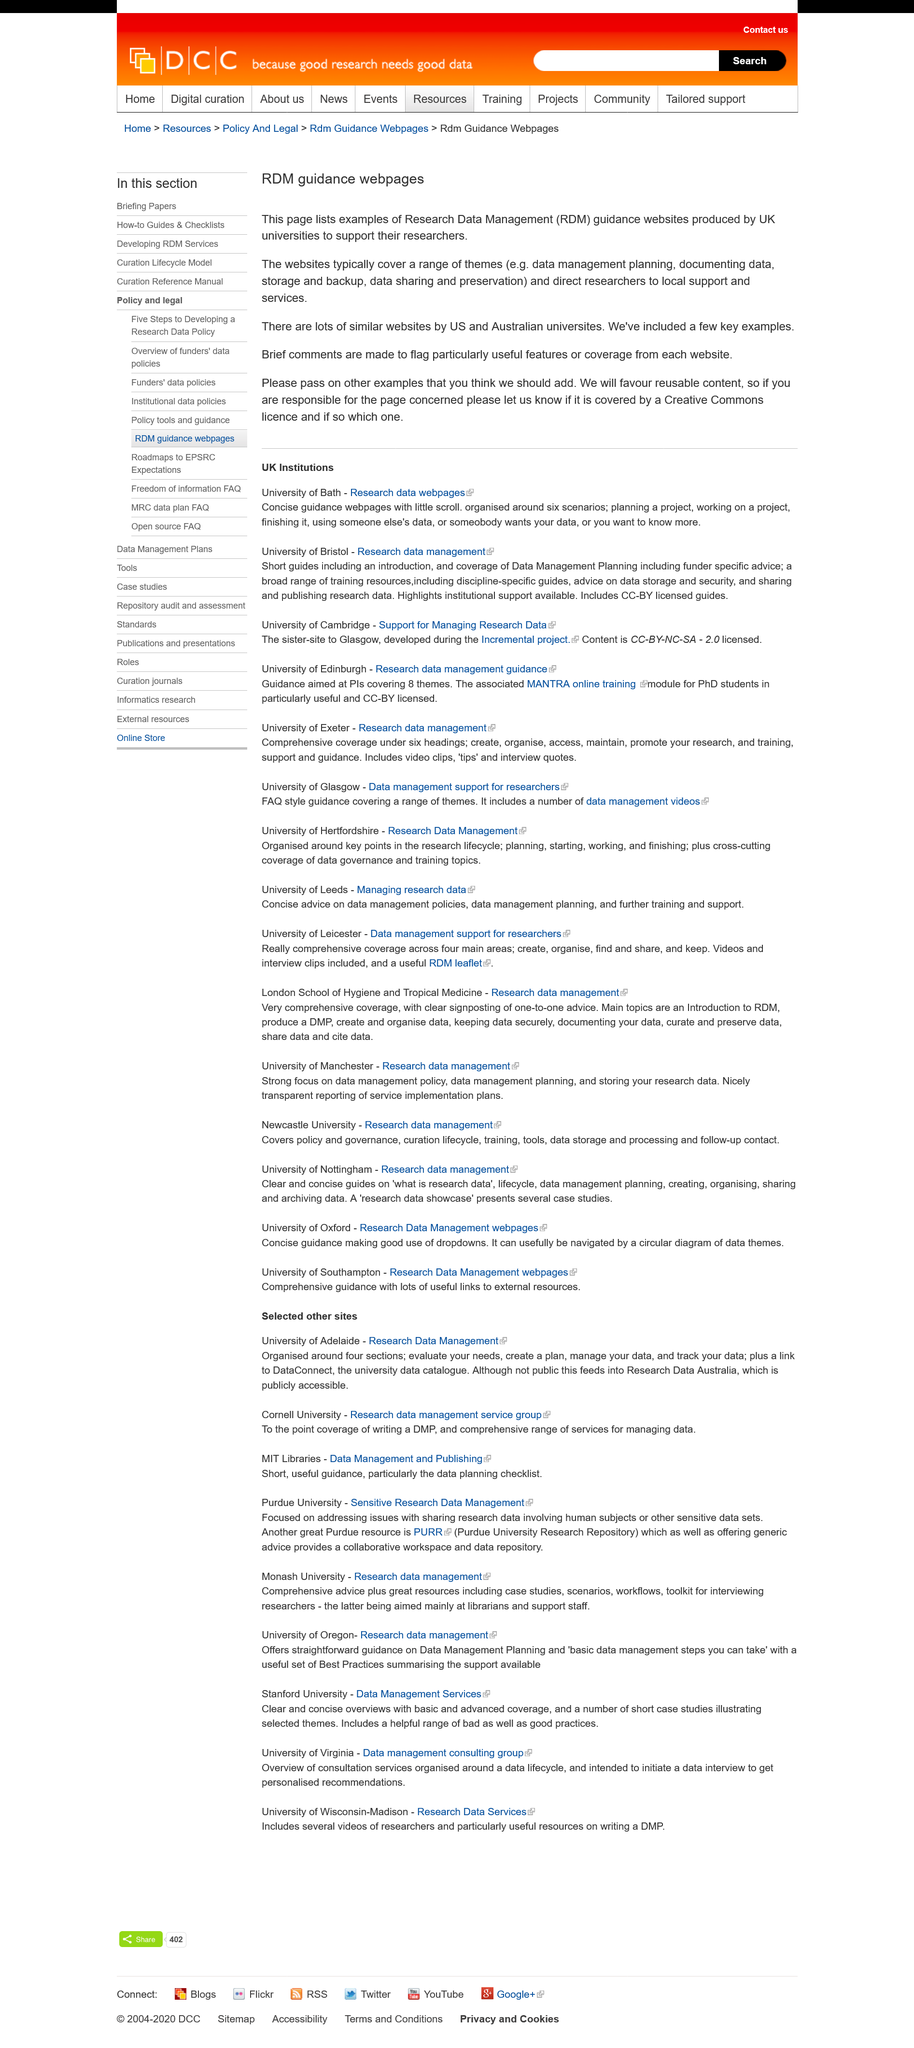Outline some significant characteristics in this image. The RDM Guidance Webpages provide a list of examples of RDM websites produced by UK universities to support their researchers in managing their research data. The websites typically cover themes related to data management, including data management planning, documenting data, storage and backup, data sharing and preservation. There exist other overseas websites that share similar characteristics as Coursera and FutureLearn. These similar websites are primarily operated by US and Australian universities. 